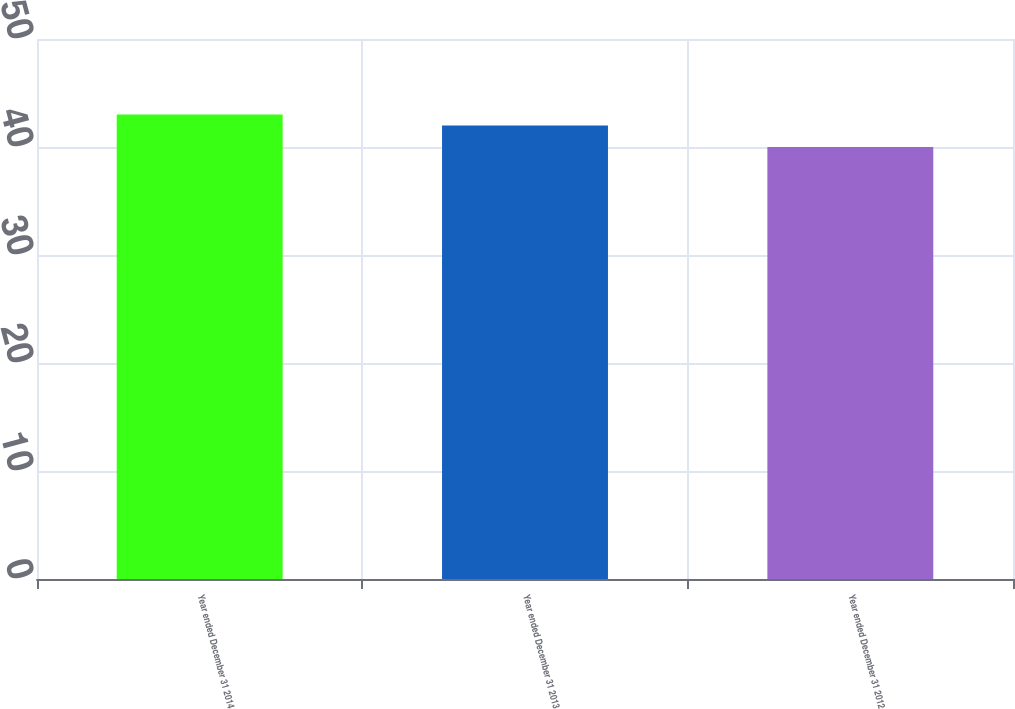Convert chart. <chart><loc_0><loc_0><loc_500><loc_500><bar_chart><fcel>Year ended December 31 2014<fcel>Year ended December 31 2013<fcel>Year ended December 31 2012<nl><fcel>43<fcel>42<fcel>40<nl></chart> 